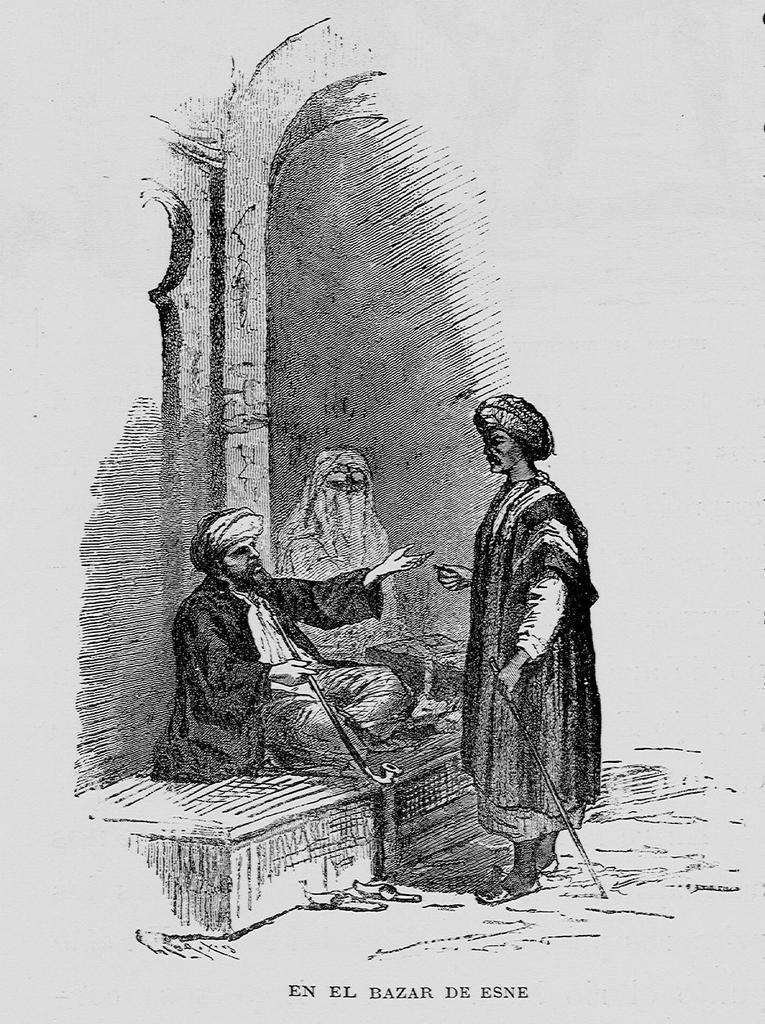What type of drawing is the image? The image is a sketch. What can be seen in the sketch? There are people in the image. Is there any text associated with the sketch? Yes, there is text at the bottom of the image. What type of potato is being used as a scarecrow in the image? There is no potato or scarecrow present in the image; it is a sketch of people with text at the bottom. 